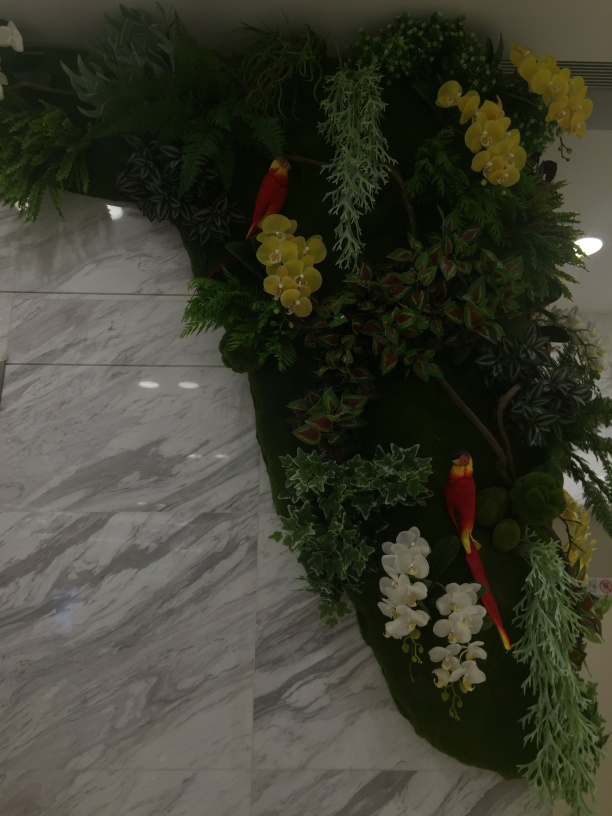Could you speculate on the type of location this image might be taken in? From the polished marble floor and the well-maintained artificial floral arrangement, this image likely depicts an indoor setting within a space that values aesthetics, such as a hotel lobby, a corporate building, or a high-end residential complex. The setting aims to be welcoming and to impart a luxurious impression. 